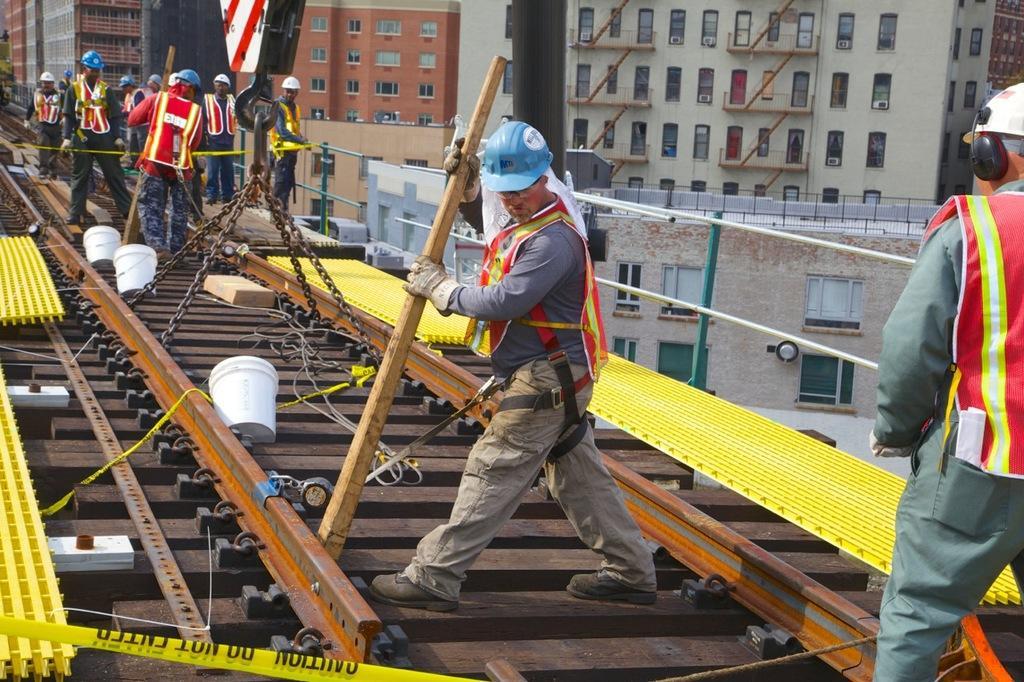Describe this image in one or two sentences. In this image we can see railway track with wooden pieces. There are buckets. And we can see a hook with chains. And there are many people. They are wearing helmets. One person is holding a stick. And he is wearing gloves. There are yellow color objects. In the background there are buildings with windows. Also we can see a railing with rods. 